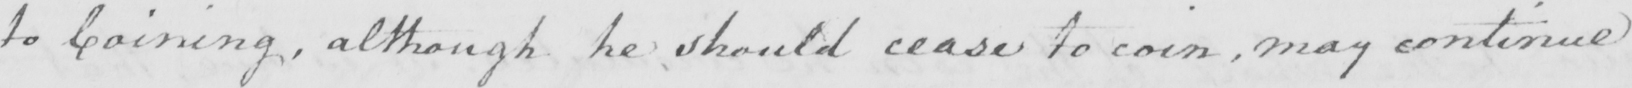Please transcribe the handwritten text in this image. to Coining , although he should cease to coin , may continue 